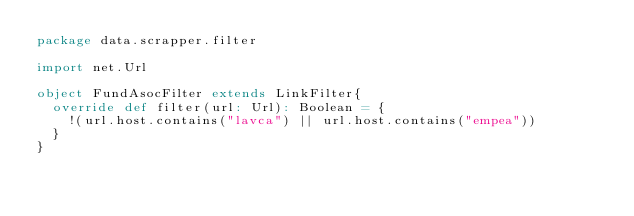<code> <loc_0><loc_0><loc_500><loc_500><_Scala_>package data.scrapper.filter

import net.Url

object FundAsocFilter extends LinkFilter{
  override def filter(url: Url): Boolean = {
    !(url.host.contains("lavca") || url.host.contains("empea"))
  }
}
</code> 